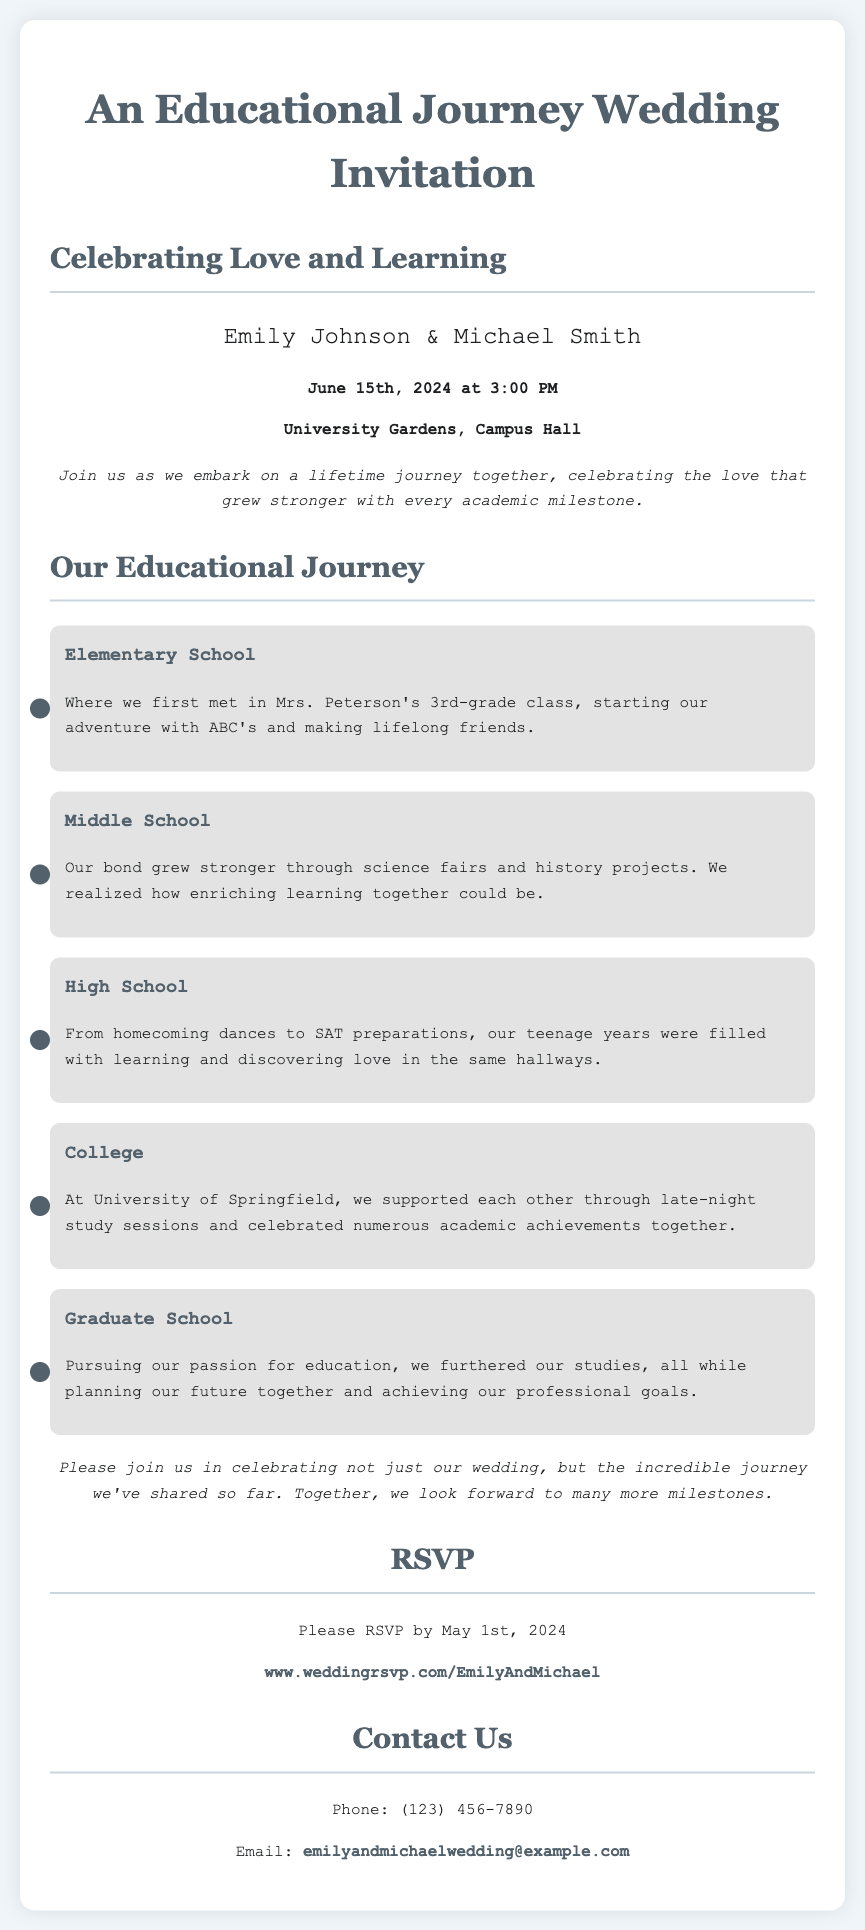What are the names of the couple? The names of the couple are clearly stated in the invitation section.
Answer: Emily Johnson & Michael Smith When is the wedding date? The wedding date is specified under the date and time section of the document.
Answer: June 15th, 2024 Where is the wedding venue? The venue is mentioned in the venue section.
Answer: University Gardens, Campus Hall What is the RSVP deadline? The RSVP deadline is listed in the RSVP section.
Answer: May 1st, 2024 What was the first educational milestone mentioned? The document lists key academic milestones in chronological order, starting with Elementary School.
Answer: Elementary School What color is used for the milestone bullet points? The visual design of the milestones indicates the color used for the bullet points.
Answer: Dark blue How many milestones are described in the invitation? The total number of educational milestones is counted from the section detailing their journey.
Answer: Five What is the main theme of the invitation? The text at the top and intro message outline the primary theme of the invitation.
Answer: Love and Learning What type of event is being celebrated? The overall context of the document describes the type of event taking place.
Answer: Wedding 